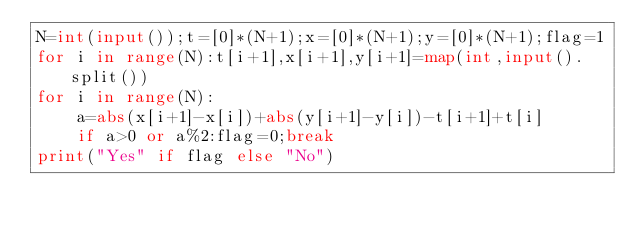<code> <loc_0><loc_0><loc_500><loc_500><_Python_>N=int(input());t=[0]*(N+1);x=[0]*(N+1);y=[0]*(N+1);flag=1
for i in range(N):t[i+1],x[i+1],y[i+1]=map(int,input().split())
for i in range(N):
    a=abs(x[i+1]-x[i])+abs(y[i+1]-y[i])-t[i+1]+t[i]
    if a>0 or a%2:flag=0;break
print("Yes" if flag else "No")
</code> 